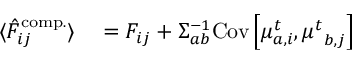<formula> <loc_0><loc_0><loc_500><loc_500>\begin{array} { r l } { \langle \hat { F } _ { i j } ^ { c o m p . } \rangle } & = { F } _ { i j } + { \Sigma } _ { a b } ^ { - 1 } C o v \left [ { \mu } _ { a , i } ^ { t } , { \mu ^ { t } } _ { b , j } \right ] } \end{array}</formula> 